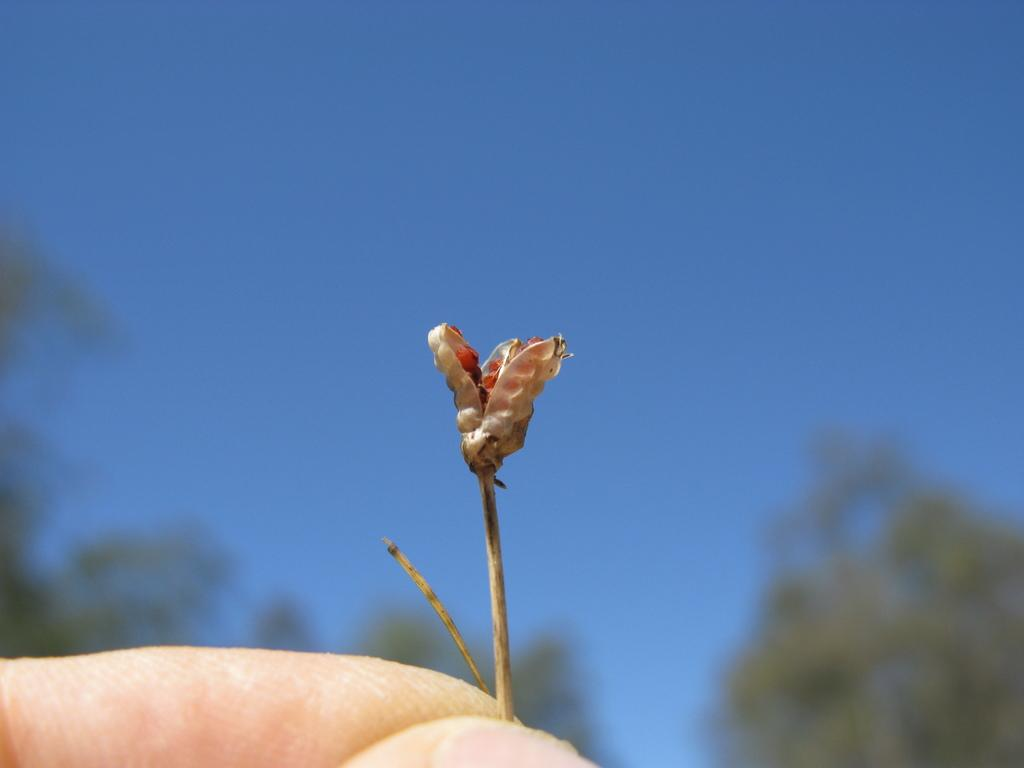What is the main subject of the image? There is a flower in the image. Who is holding the flower? The flower is being held by a person. What can be seen in the background of the image? There are trees visible in the background of the image. What type of animal can be seen in the zoo in the image? There is no zoo or animal present in the image; it features a person holding a flower with trees in the background. 